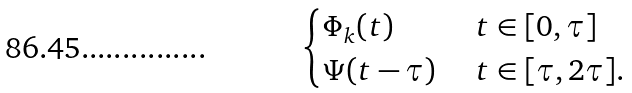Convert formula to latex. <formula><loc_0><loc_0><loc_500><loc_500>\begin{cases} \Phi _ { k } ( t ) & \text { } t \in [ 0 , \tau ] \\ \Psi ( t - \tau ) & \text { } t \in [ \tau , 2 \tau ] . \end{cases}</formula> 